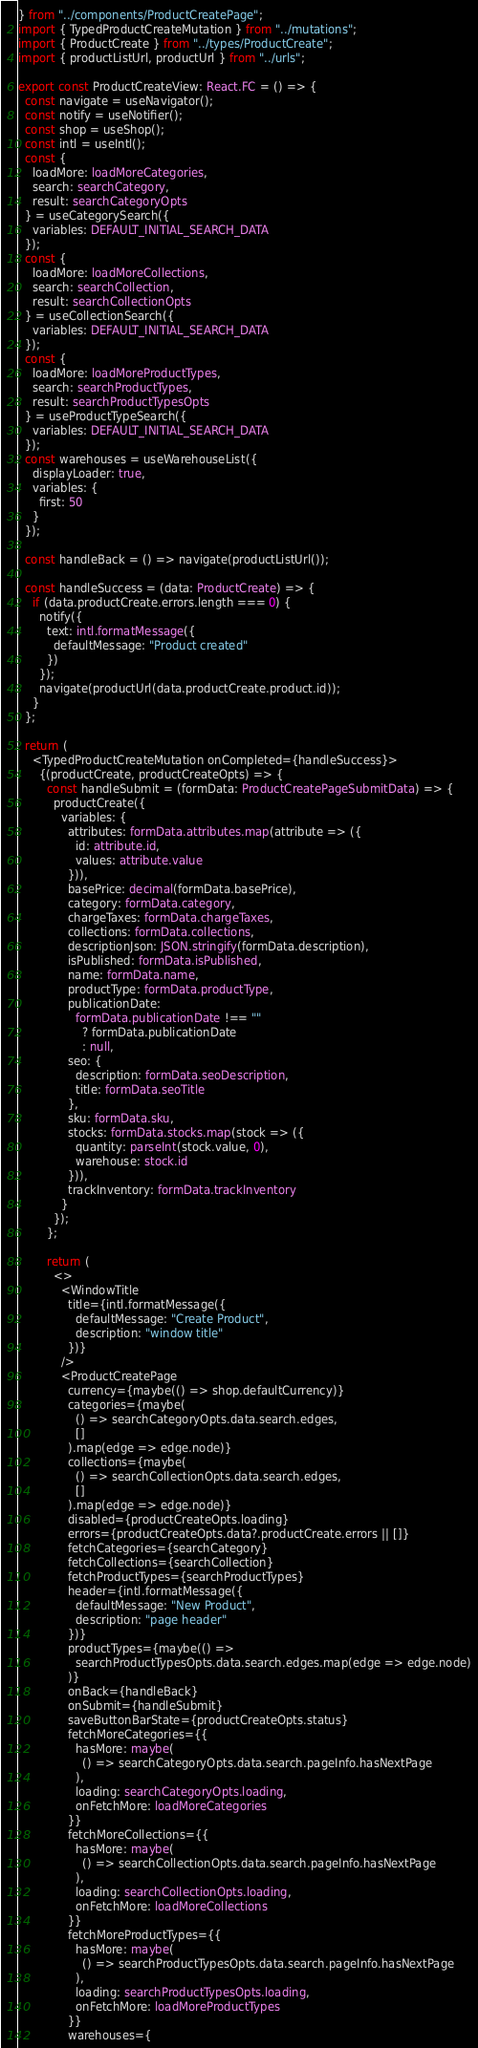Convert code to text. <code><loc_0><loc_0><loc_500><loc_500><_TypeScript_>} from "../components/ProductCreatePage";
import { TypedProductCreateMutation } from "../mutations";
import { ProductCreate } from "../types/ProductCreate";
import { productListUrl, productUrl } from "../urls";

export const ProductCreateView: React.FC = () => {
  const navigate = useNavigator();
  const notify = useNotifier();
  const shop = useShop();
  const intl = useIntl();
  const {
    loadMore: loadMoreCategories,
    search: searchCategory,
    result: searchCategoryOpts
  } = useCategorySearch({
    variables: DEFAULT_INITIAL_SEARCH_DATA
  });
  const {
    loadMore: loadMoreCollections,
    search: searchCollection,
    result: searchCollectionOpts
  } = useCollectionSearch({
    variables: DEFAULT_INITIAL_SEARCH_DATA
  });
  const {
    loadMore: loadMoreProductTypes,
    search: searchProductTypes,
    result: searchProductTypesOpts
  } = useProductTypeSearch({
    variables: DEFAULT_INITIAL_SEARCH_DATA
  });
  const warehouses = useWarehouseList({
    displayLoader: true,
    variables: {
      first: 50
    }
  });

  const handleBack = () => navigate(productListUrl());

  const handleSuccess = (data: ProductCreate) => {
    if (data.productCreate.errors.length === 0) {
      notify({
        text: intl.formatMessage({
          defaultMessage: "Product created"
        })
      });
      navigate(productUrl(data.productCreate.product.id));
    }
  };

  return (
    <TypedProductCreateMutation onCompleted={handleSuccess}>
      {(productCreate, productCreateOpts) => {
        const handleSubmit = (formData: ProductCreatePageSubmitData) => {
          productCreate({
            variables: {
              attributes: formData.attributes.map(attribute => ({
                id: attribute.id,
                values: attribute.value
              })),
              basePrice: decimal(formData.basePrice),
              category: formData.category,
              chargeTaxes: formData.chargeTaxes,
              collections: formData.collections,
              descriptionJson: JSON.stringify(formData.description),
              isPublished: formData.isPublished,
              name: formData.name,
              productType: formData.productType,
              publicationDate:
                formData.publicationDate !== ""
                  ? formData.publicationDate
                  : null,
              seo: {
                description: formData.seoDescription,
                title: formData.seoTitle
              },
              sku: formData.sku,
              stocks: formData.stocks.map(stock => ({
                quantity: parseInt(stock.value, 0),
                warehouse: stock.id
              })),
              trackInventory: formData.trackInventory
            }
          });
        };

        return (
          <>
            <WindowTitle
              title={intl.formatMessage({
                defaultMessage: "Create Product",
                description: "window title"
              })}
            />
            <ProductCreatePage
              currency={maybe(() => shop.defaultCurrency)}
              categories={maybe(
                () => searchCategoryOpts.data.search.edges,
                []
              ).map(edge => edge.node)}
              collections={maybe(
                () => searchCollectionOpts.data.search.edges,
                []
              ).map(edge => edge.node)}
              disabled={productCreateOpts.loading}
              errors={productCreateOpts.data?.productCreate.errors || []}
              fetchCategories={searchCategory}
              fetchCollections={searchCollection}
              fetchProductTypes={searchProductTypes}
              header={intl.formatMessage({
                defaultMessage: "New Product",
                description: "page header"
              })}
              productTypes={maybe(() =>
                searchProductTypesOpts.data.search.edges.map(edge => edge.node)
              )}
              onBack={handleBack}
              onSubmit={handleSubmit}
              saveButtonBarState={productCreateOpts.status}
              fetchMoreCategories={{
                hasMore: maybe(
                  () => searchCategoryOpts.data.search.pageInfo.hasNextPage
                ),
                loading: searchCategoryOpts.loading,
                onFetchMore: loadMoreCategories
              }}
              fetchMoreCollections={{
                hasMore: maybe(
                  () => searchCollectionOpts.data.search.pageInfo.hasNextPage
                ),
                loading: searchCollectionOpts.loading,
                onFetchMore: loadMoreCollections
              }}
              fetchMoreProductTypes={{
                hasMore: maybe(
                  () => searchProductTypesOpts.data.search.pageInfo.hasNextPage
                ),
                loading: searchProductTypesOpts.loading,
                onFetchMore: loadMoreProductTypes
              }}
              warehouses={</code> 